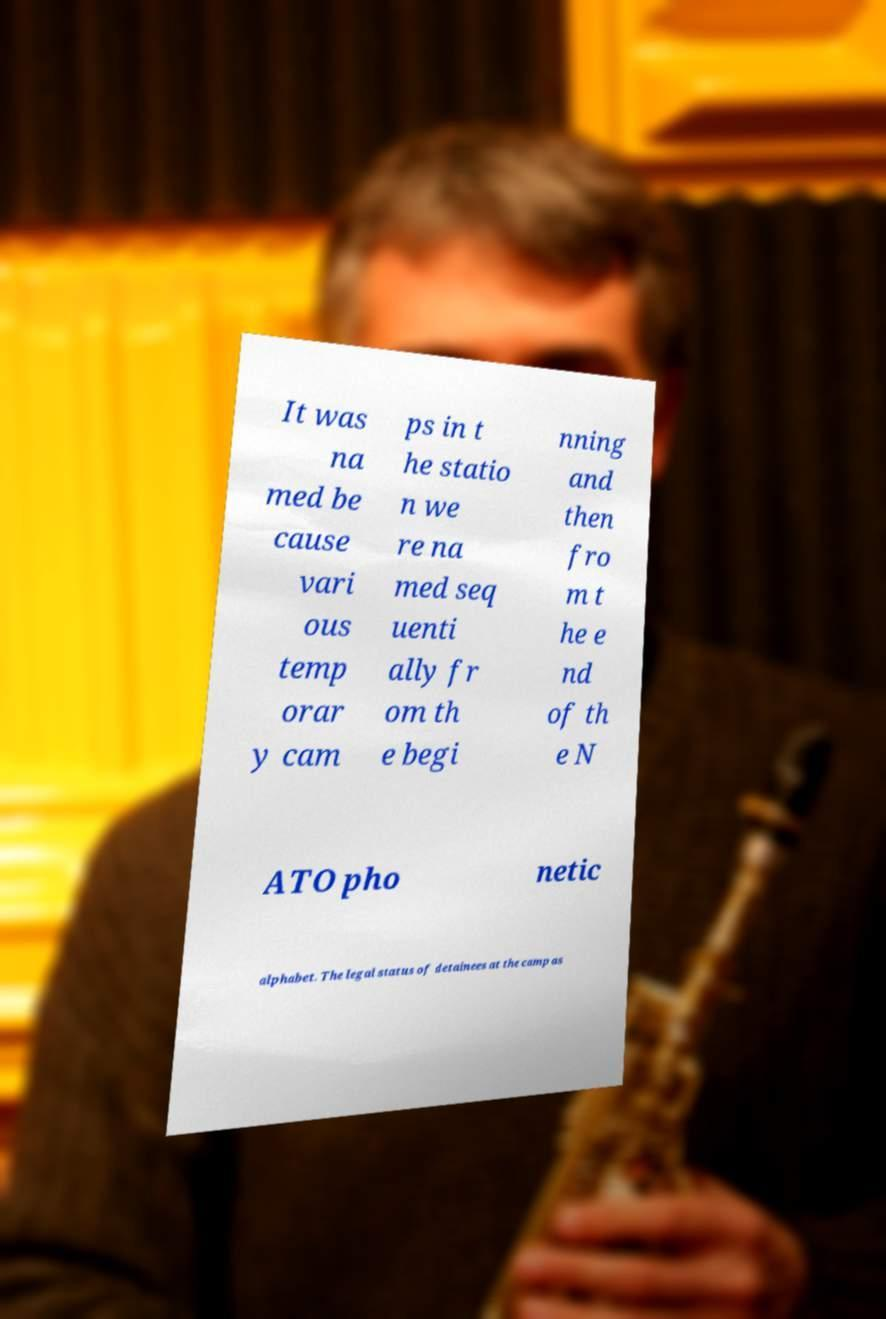What messages or text are displayed in this image? I need them in a readable, typed format. It was na med be cause vari ous temp orar y cam ps in t he statio n we re na med seq uenti ally fr om th e begi nning and then fro m t he e nd of th e N ATO pho netic alphabet. The legal status of detainees at the camp as 